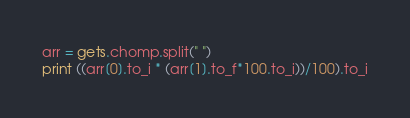Convert code to text. <code><loc_0><loc_0><loc_500><loc_500><_Ruby_>arr = gets.chomp.split(" ")
print ((arr[0].to_i * (arr[1].to_f*100.to_i))/100).to_i
</code> 